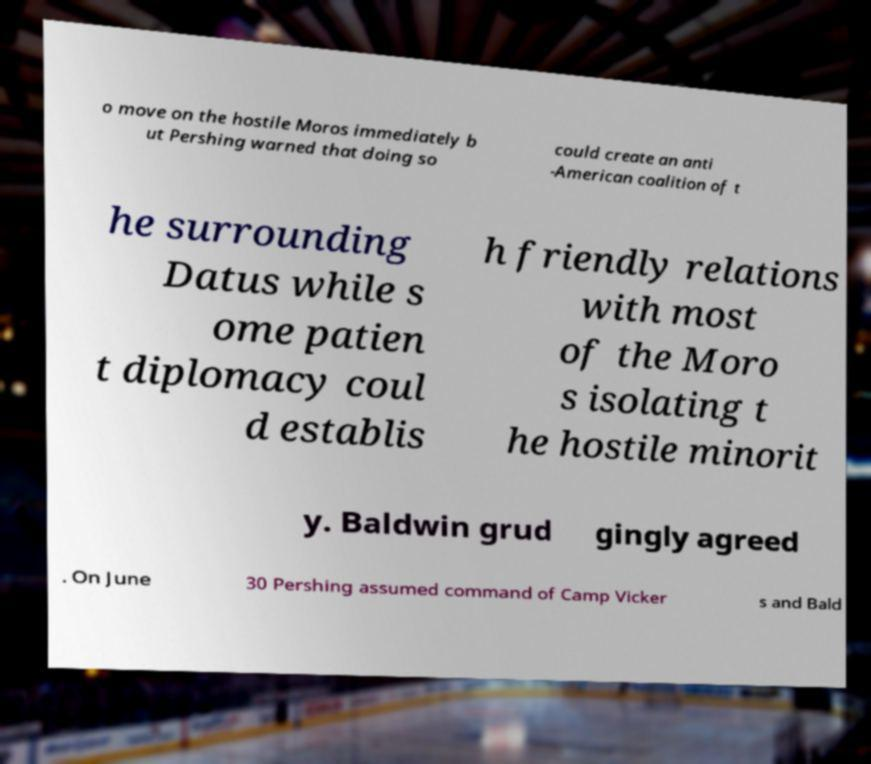For documentation purposes, I need the text within this image transcribed. Could you provide that? o move on the hostile Moros immediately b ut Pershing warned that doing so could create an anti -American coalition of t he surrounding Datus while s ome patien t diplomacy coul d establis h friendly relations with most of the Moro s isolating t he hostile minorit y. Baldwin grud gingly agreed . On June 30 Pershing assumed command of Camp Vicker s and Bald 